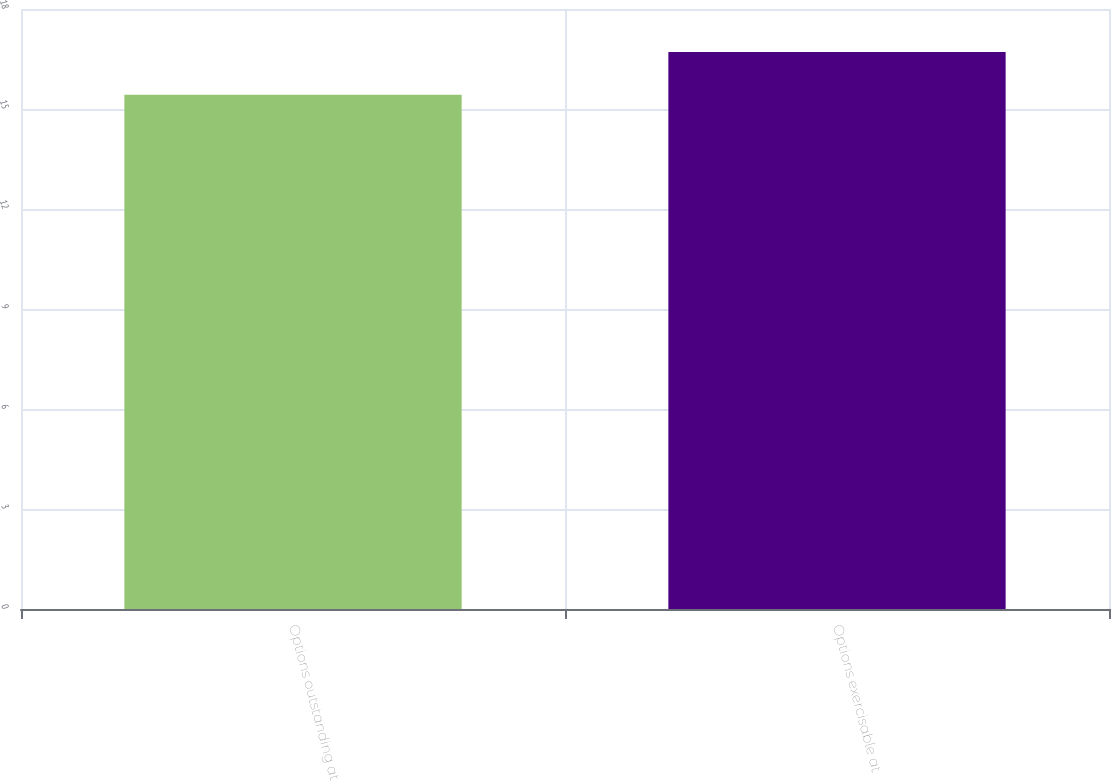Convert chart to OTSL. <chart><loc_0><loc_0><loc_500><loc_500><bar_chart><fcel>Options outstanding at<fcel>Options exercisable at<nl><fcel>15.43<fcel>16.71<nl></chart> 